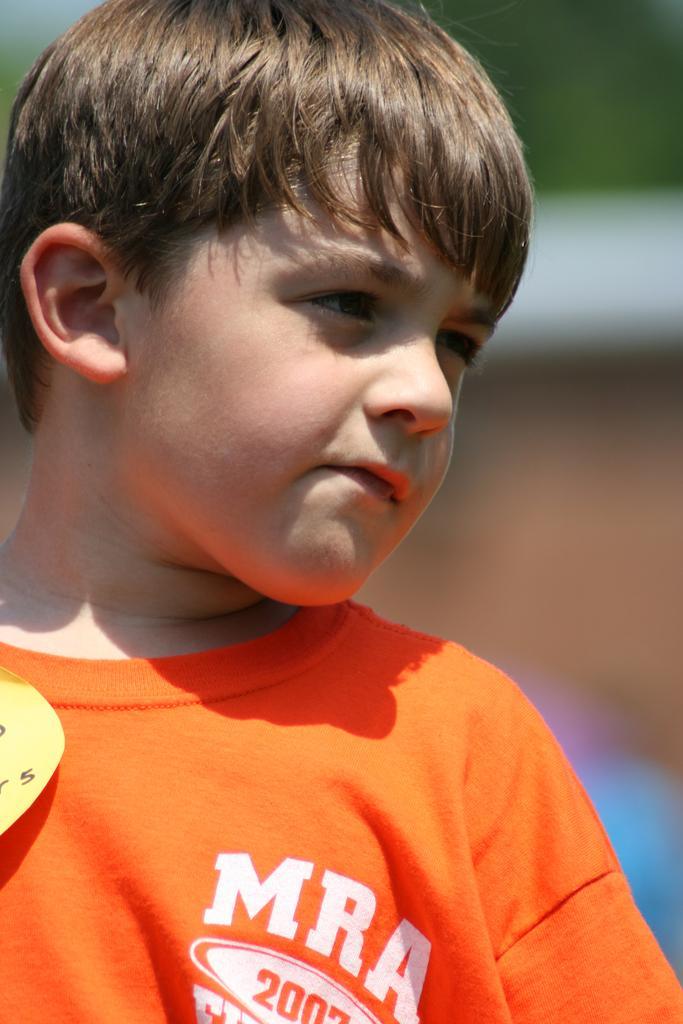Please provide a concise description of this image. This image consists of a boy. He is wearing an orange shirt. 